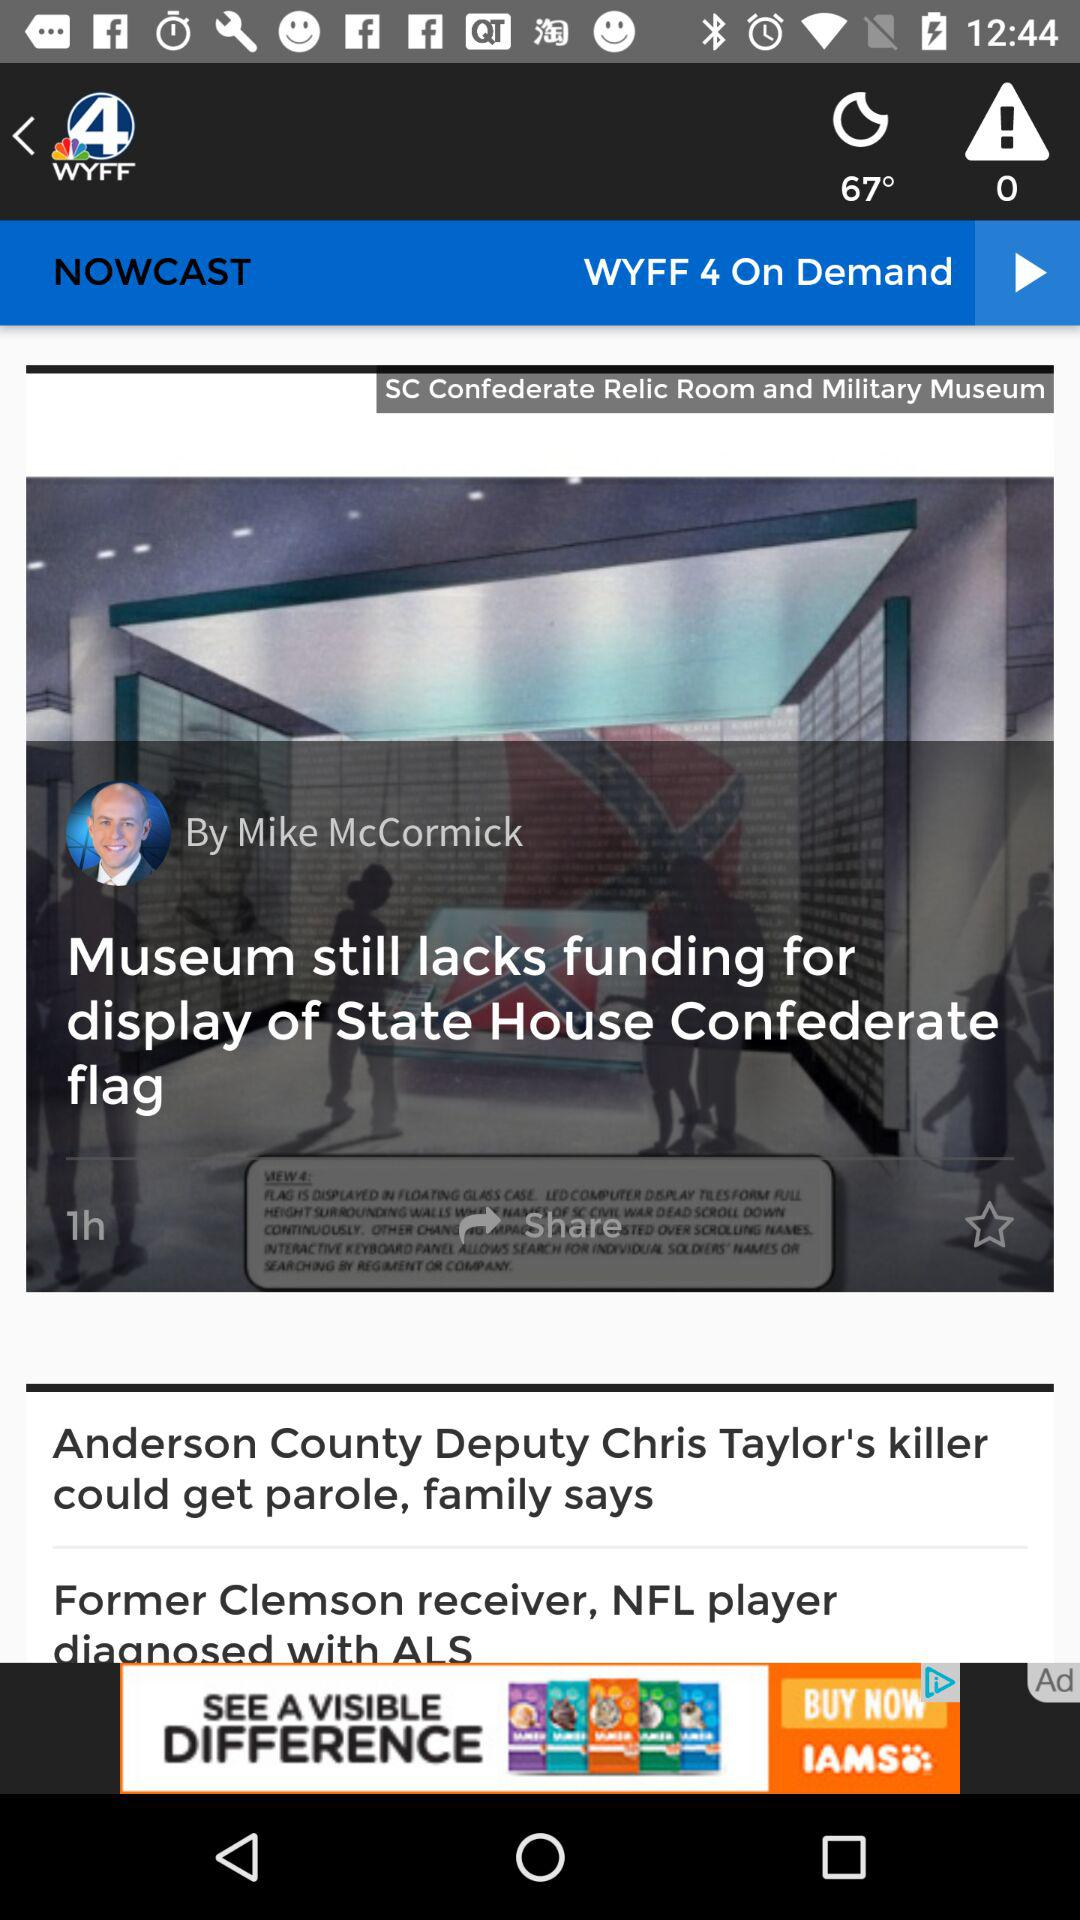How many alerts are there? There are 0 alerts. 